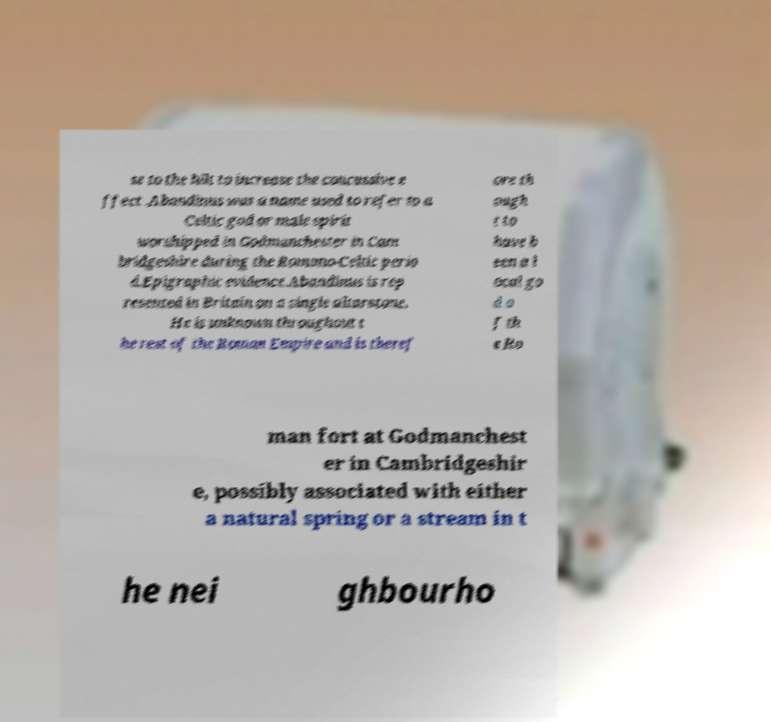Could you assist in decoding the text presented in this image and type it out clearly? se to the hilt to increase the concussive e ffect .Abandinus was a name used to refer to a Celtic god or male spirit worshipped in Godmanchester in Cam bridgeshire during the Romano-Celtic perio d.Epigraphic evidence.Abandinus is rep resented in Britain on a single altarstone. He is unknown throughout t he rest of the Roman Empire and is theref ore th ough t to have b een a l ocal go d o f th e Ro man fort at Godmanchest er in Cambridgeshir e, possibly associated with either a natural spring or a stream in t he nei ghbourho 